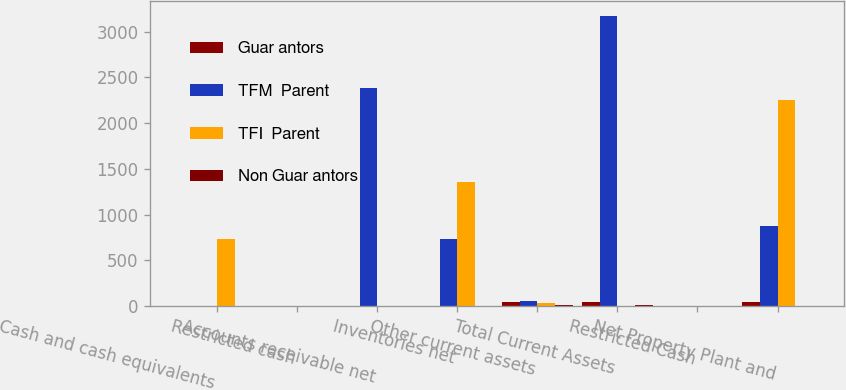Convert chart to OTSL. <chart><loc_0><loc_0><loc_500><loc_500><stacked_bar_chart><ecel><fcel>Cash and cash equivalents<fcel>Restricted cash<fcel>Accounts receivable net<fcel>Inventories net<fcel>Other current assets<fcel>Total Current Assets<fcel>Restricted Cash<fcel>Net Property Plant and<nl><fcel>Guar antors<fcel>2<fcel>0<fcel>0<fcel>0<fcel>43<fcel>45<fcel>0<fcel>39<nl><fcel>TFM  Parent<fcel>2<fcel>0<fcel>2389<fcel>734<fcel>49<fcel>3174<fcel>0<fcel>870<nl><fcel>TFI  Parent<fcel>731<fcel>0<fcel>2<fcel>1361<fcel>27<fcel>2<fcel>0<fcel>2257<nl><fcel>Non Guar antors<fcel>0<fcel>0<fcel>0<fcel>0<fcel>9<fcel>9<fcel>0<fcel>0<nl></chart> 